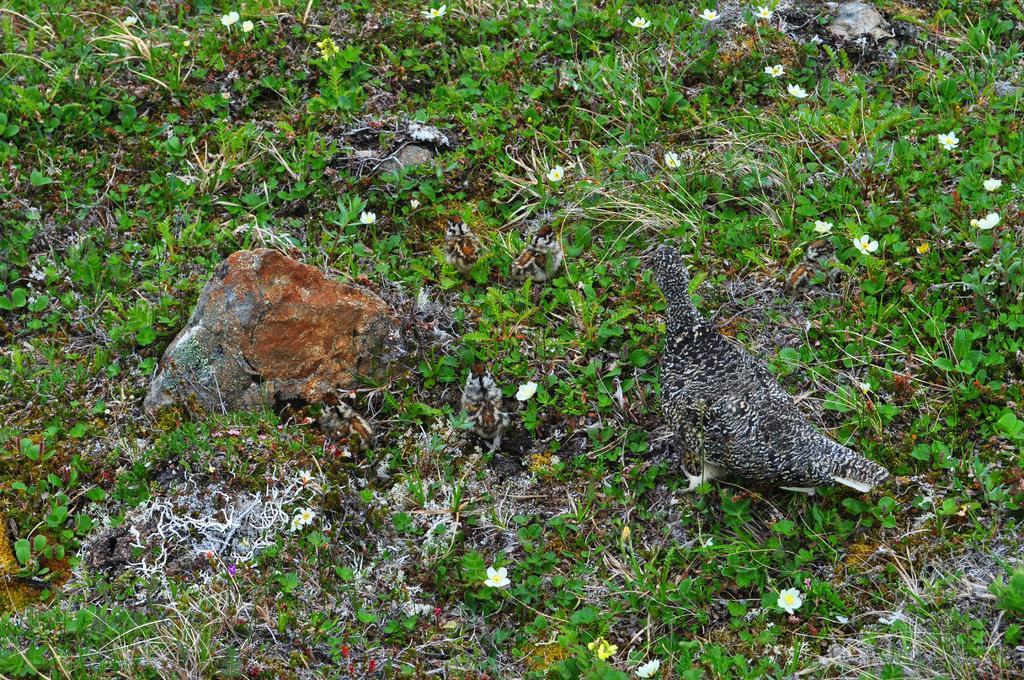Please provide a concise description of this image. In this picture we can see a bird, stones, tiny plants and the flowers. 